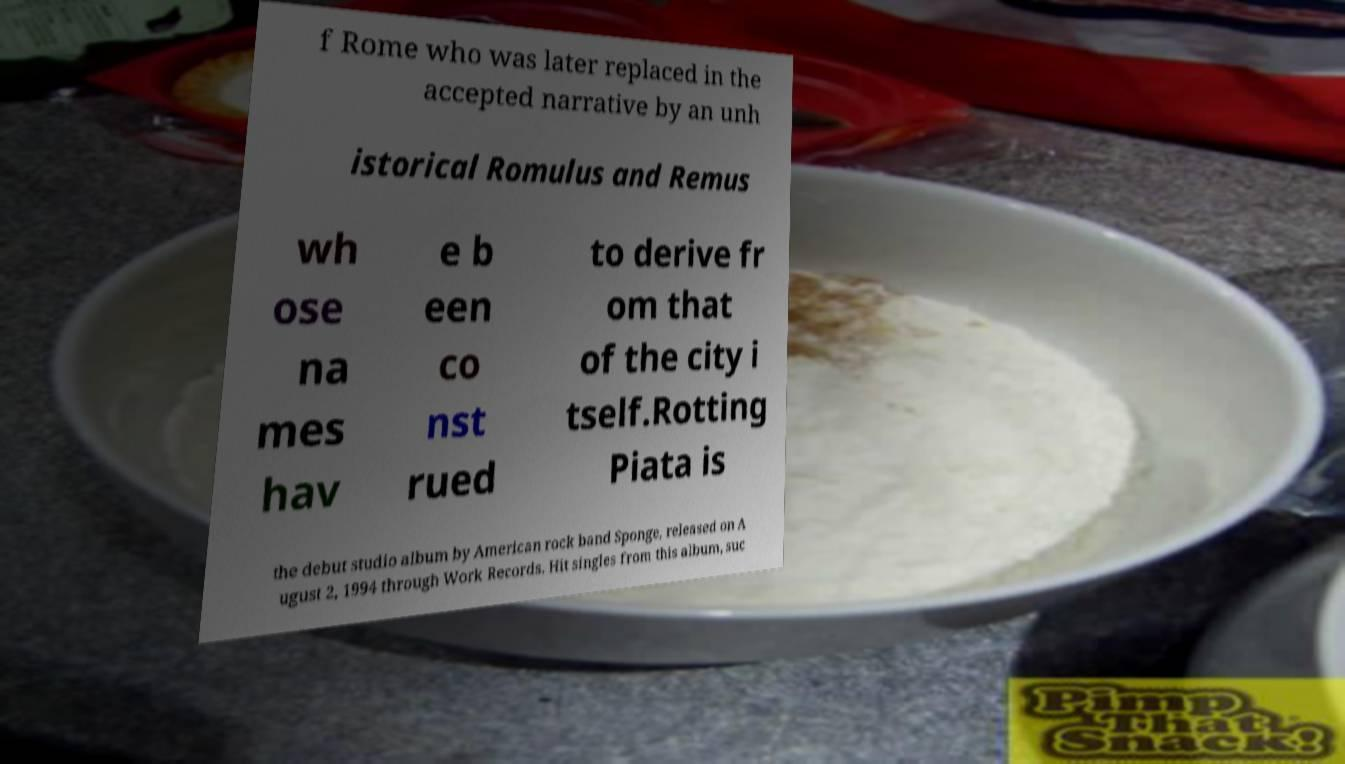Please read and relay the text visible in this image. What does it say? f Rome who was later replaced in the accepted narrative by an unh istorical Romulus and Remus wh ose na mes hav e b een co nst rued to derive fr om that of the city i tself.Rotting Piata is the debut studio album by American rock band Sponge, released on A ugust 2, 1994 through Work Records. Hit singles from this album, suc 